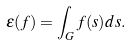Convert formula to latex. <formula><loc_0><loc_0><loc_500><loc_500>\epsilon ( f ) = \int _ { G } f ( s ) d s .</formula> 